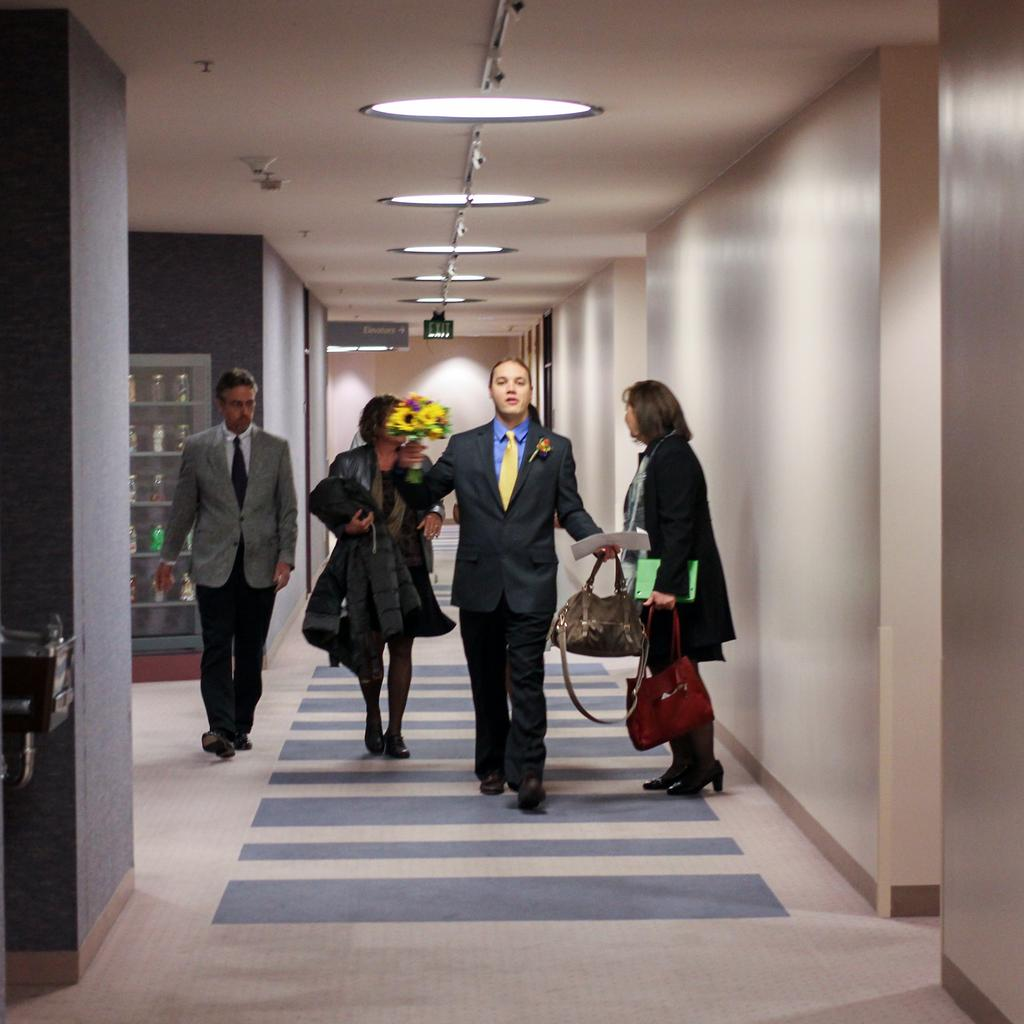What are the people in the image doing? The people in the image are walking. What might the bags held by some people be used for? The bags held by some people might be used for carrying items or belongings. What can be seen on the shelf in the image? There is a shelf filled with objects in the image. What is the source of light near the roof in the image? The source of light near the roof is not specified in the image. What type of machine is being powered by the wheel in the image? There is no machine or wheel present in the image. 